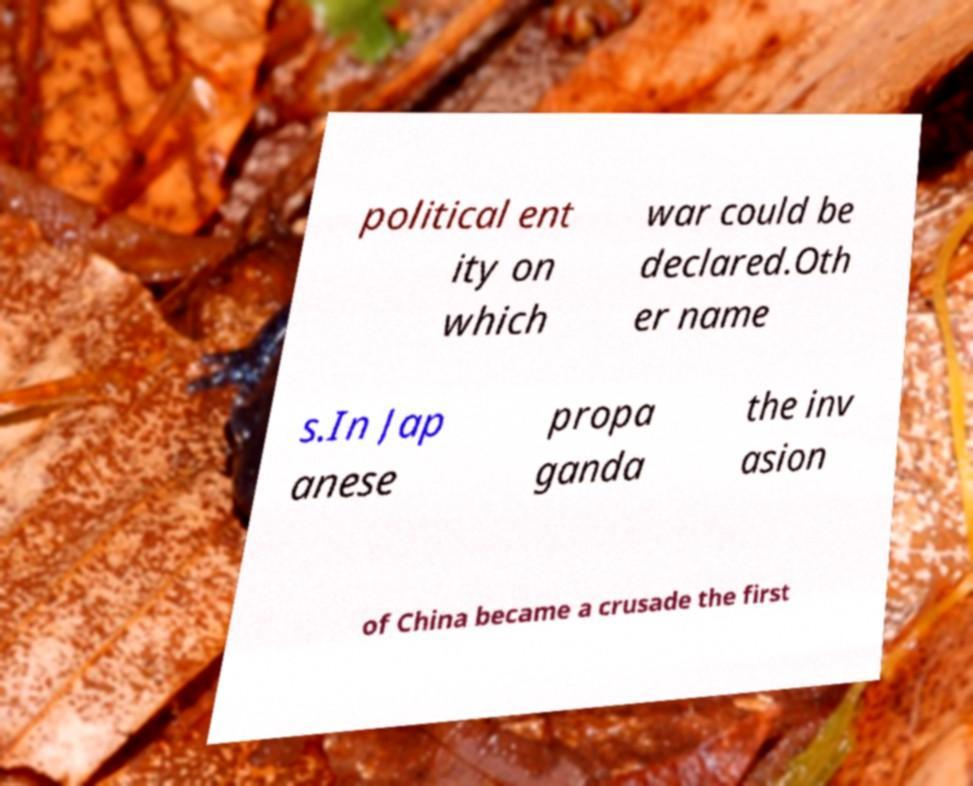Please identify and transcribe the text found in this image. political ent ity on which war could be declared.Oth er name s.In Jap anese propa ganda the inv asion of China became a crusade the first 